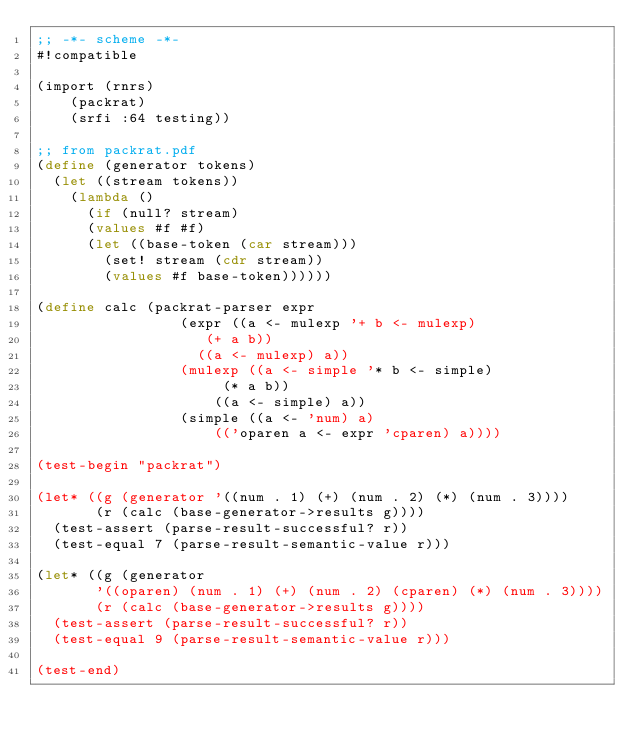Convert code to text. <code><loc_0><loc_0><loc_500><loc_500><_Scheme_>;; -*- scheme -*-
#!compatible

(import (rnrs)
	(packrat)
	(srfi :64 testing))

;; from packrat.pdf
(define (generator tokens)
  (let ((stream tokens))
    (lambda ()
      (if (null? stream)
	  (values #f #f)
	  (let ((base-token (car stream)))
	    (set! stream (cdr stream))
	    (values #f base-token))))))

(define calc (packrat-parser expr
			     (expr ((a <- mulexp '+ b <- mulexp)
				    (+ a b))
				   ((a <- mulexp) a))
			     (mulexp ((a <- simple '* b <- simple)
				      (* a b))
				     ((a <- simple) a))
			     (simple ((a <- 'num) a)
				     (('oparen a <- expr 'cparen) a))))

(test-begin "packrat")

(let* ((g (generator '((num . 1) (+) (num . 2) (*) (num . 3))))
       (r (calc (base-generator->results g))))
  (test-assert (parse-result-successful? r))
  (test-equal 7 (parse-result-semantic-value r)))

(let* ((g (generator
	   '((oparen) (num . 1) (+) (num . 2) (cparen) (*) (num . 3))))
       (r (calc (base-generator->results g))))
  (test-assert (parse-result-successful? r))
  (test-equal 9 (parse-result-semantic-value r)))

(test-end)
</code> 